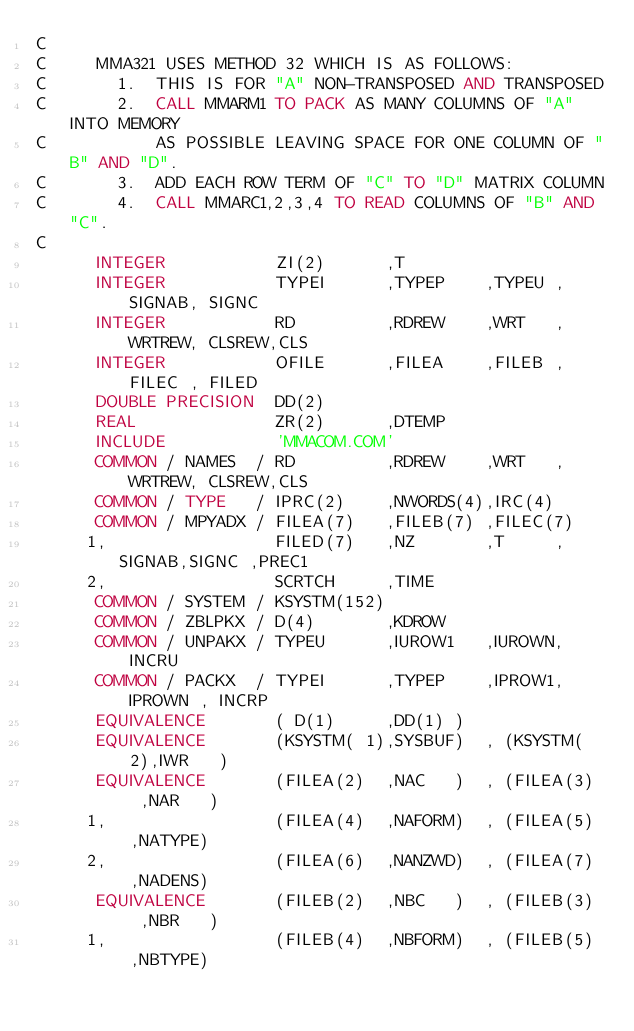Convert code to text. <code><loc_0><loc_0><loc_500><loc_500><_FORTRAN_>C     
C     MMA321 USES METHOD 32 WHICH IS AS FOLLOWS:
C       1.  THIS IS FOR "A" NON-TRANSPOSED AND TRANSPOSED
C       2.  CALL MMARM1 TO PACK AS MANY COLUMNS OF "A" INTO MEMORY 
C           AS POSSIBLE LEAVING SPACE FOR ONE COLUMN OF "B" AND "D".
C       3.  ADD EACH ROW TERM OF "C" TO "D" MATRIX COLUMN
C       4.  CALL MMARC1,2,3,4 TO READ COLUMNS OF "B" AND "C".
C
      INTEGER           ZI(2)      ,T
      INTEGER           TYPEI      ,TYPEP    ,TYPEU ,SIGNAB, SIGNC
      INTEGER           RD         ,RDREW    ,WRT   ,WRTREW, CLSREW,CLS
      INTEGER           OFILE      ,FILEA    ,FILEB ,FILEC , FILED
      DOUBLE PRECISION  DD(2)
      REAL              ZR(2)      ,DTEMP
      INCLUDE           'MMACOM.COM'     
      COMMON / NAMES  / RD         ,RDREW    ,WRT   ,WRTREW, CLSREW,CLS
      COMMON / TYPE   / IPRC(2)    ,NWORDS(4),IRC(4)
      COMMON / MPYADX / FILEA(7)   ,FILEB(7) ,FILEC(7)    
     1,                 FILED(7)   ,NZ       ,T     ,SIGNAB,SIGNC ,PREC1 
     2,                 SCRTCH     ,TIME
      COMMON / SYSTEM / KSYSTM(152)
      COMMON / ZBLPKX / D(4)       ,KDROW
      COMMON / UNPAKX / TYPEU      ,IUROW1   ,IUROWN, INCRU
      COMMON / PACKX  / TYPEI      ,TYPEP    ,IPROW1, IPROWN , INCRP
      EQUIVALENCE       ( D(1)     ,DD(1) )
      EQUIVALENCE       (KSYSTM( 1),SYSBUF)  , (KSYSTM( 2),IWR   ) 
      EQUIVALENCE       (FILEA(2)  ,NAC   )  , (FILEA(3)  ,NAR   )
     1,                 (FILEA(4)  ,NAFORM)  , (FILEA(5)  ,NATYPE)
     2,                 (FILEA(6)  ,NANZWD)  , (FILEA(7)  ,NADENS)
      EQUIVALENCE       (FILEB(2)  ,NBC   )  , (FILEB(3)  ,NBR   )
     1,                 (FILEB(4)  ,NBFORM)  , (FILEB(5)  ,NBTYPE)</code> 